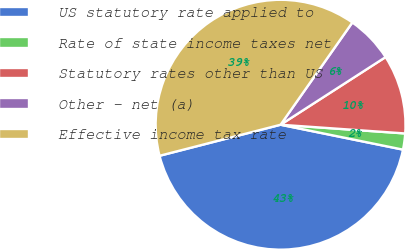Convert chart. <chart><loc_0><loc_0><loc_500><loc_500><pie_chart><fcel>US statutory rate applied to<fcel>Rate of state income taxes net<fcel>Statutory rates other than US<fcel>Other - net (a)<fcel>Effective income tax rate<nl><fcel>42.81%<fcel>2.08%<fcel>10.22%<fcel>6.15%<fcel>38.74%<nl></chart> 